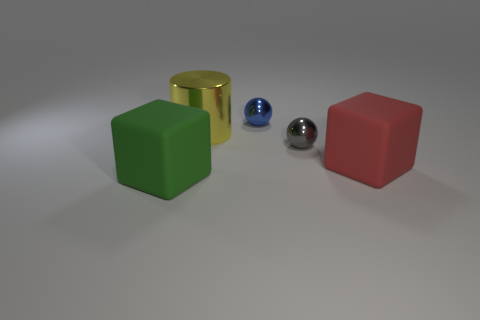Add 1 large purple things. How many objects exist? 6 Subtract all cylinders. How many objects are left? 4 Add 1 big red shiny things. How many big red shiny things exist? 1 Subtract 0 gray cylinders. How many objects are left? 5 Subtract all yellow metal objects. Subtract all gray spheres. How many objects are left? 3 Add 2 large objects. How many large objects are left? 5 